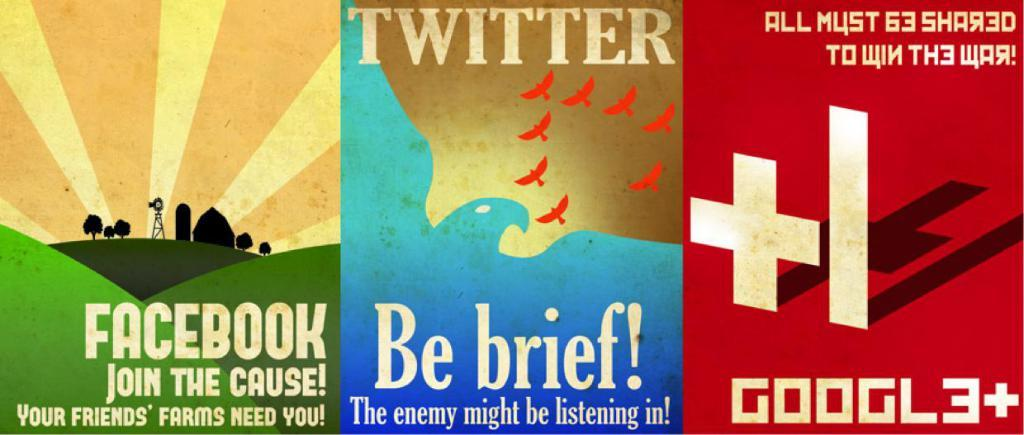<image>
Render a clear and concise summary of the photo. A set of posters includes one that says Twitter and "be brief". 